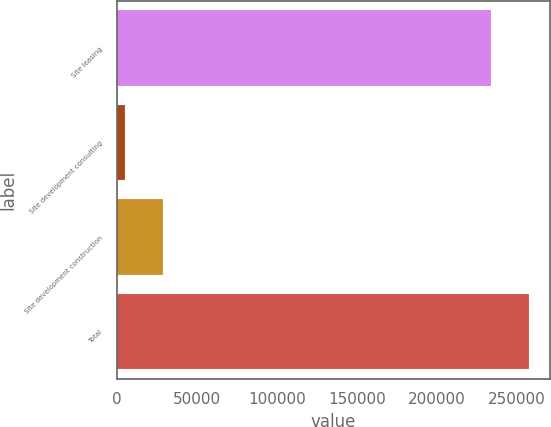<chart> <loc_0><loc_0><loc_500><loc_500><bar_chart><fcel>Site leasing<fcel>Site development consulting<fcel>Site development construction<fcel>Total<nl><fcel>233812<fcel>5054<fcel>29033.4<fcel>257791<nl></chart> 